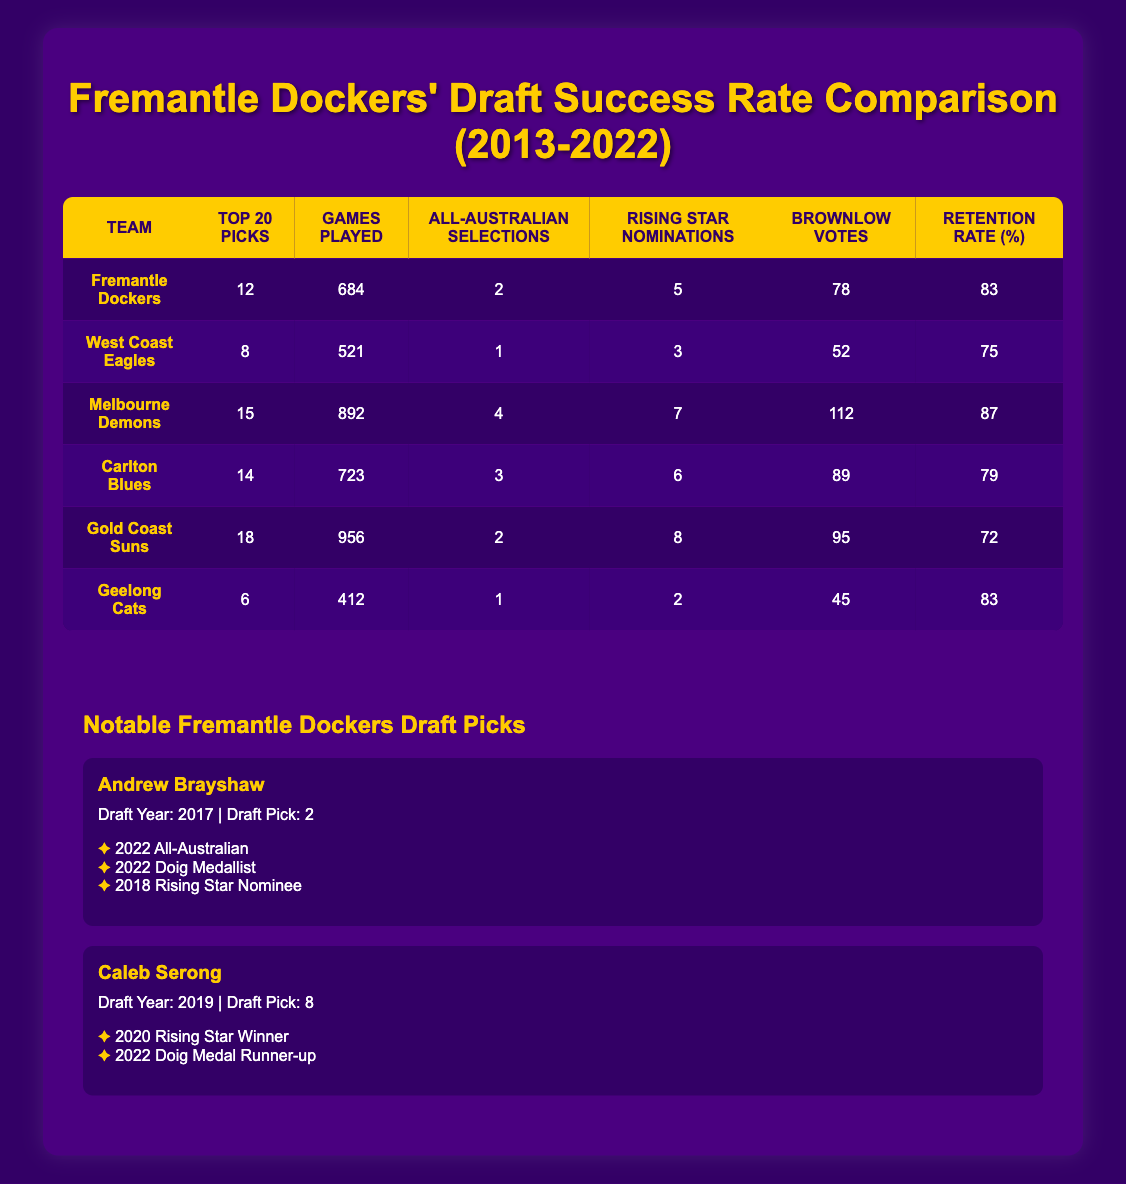What is the retention rate of Fremantle Dockers' draft picks? The retention rate for the Fremantle Dockers, according to the table, is found in the last column for their row. It shows that the retention rate is 83%.
Answer: 83% How many games did top 20 picks from Melbourne Demons play? The total games played by top 20 picks from Melbourne Demons can be found in their respective row under the "Games Played" column, which indicates they played 892 games.
Answer: 892 Do the Gold Coast Suns have a higher retention rate than the West Coast Eagles? The retention rate for Gold Coast Suns is 72%, while the West Coast Eagles' retention rate is 75%. Since 72% is less than 75%, the statement is false.
Answer: No Which team had the highest number of top 20 picks? By comparing the "Top 20 Picks" column for all teams, Gold Coast Suns had the highest number with 18 top 20 picks.
Answer: 18 What is the total number of Brownlow votes received by Fremantle Dockers and Carlton Blues combined? To find this, sum the Brownlow Votes for both teams. Fremantle Dockers had 78 votes, and Carlton Blues had 89 votes. So, 78 + 89 = 167.
Answer: 167 Is it true that Fremantle Dockers have more All-Australian selections than the Geelong Cats? Fremantle Dockers had 2 All-Australian selections, while Geelong Cats had 1. Since 2 is greater than 1, the statement is true.
Answer: Yes What is the average number of Rising Star nominations among the teams listed? To find the average, sum the Rising Star nominations of all teams: 5 (Fremantle) + 3 (West Coast) + 7 (Melbourne) + 6 (Carlton) + 8 (Gold Coast) + 2 (Geelong) = 31. There are 6 teams, so the average is 31 / 6 ≈ 5.17.
Answer: 5.17 Which team has the lowest number of games played by their top 20 picks? By inspecting the "Games Played" column, the Geelong Cats have the lowest games played with 412.
Answer: 412 How many All-Australian selections do Fremantle Dockers have compared to Gold Coast Suns? Fremantle Dockers have 2 All-Australian selections and Gold Coast Suns have 2 as well. Therefore, both teams have an equal number of selections.
Answer: Equal 